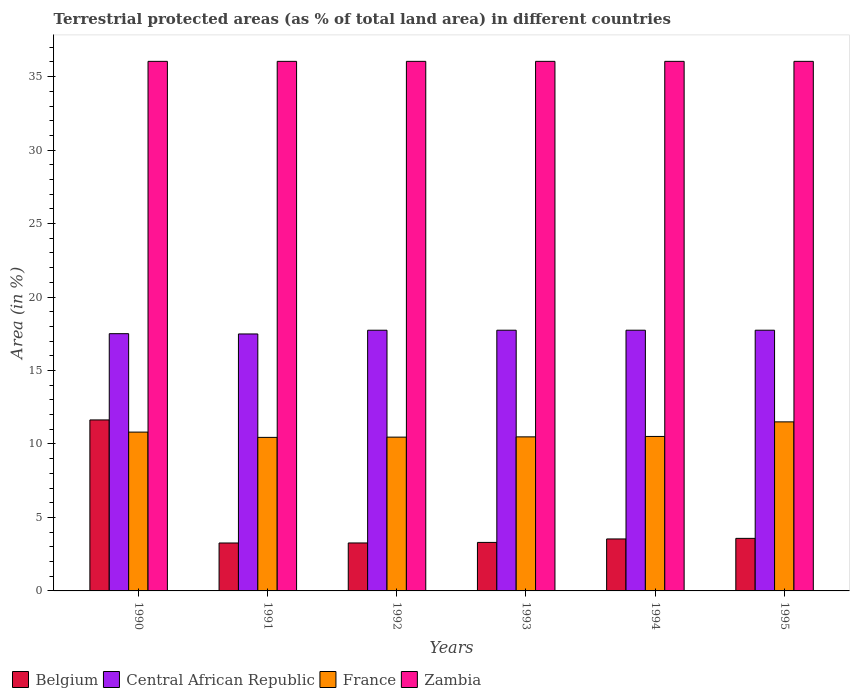How many different coloured bars are there?
Your response must be concise. 4. How many groups of bars are there?
Give a very brief answer. 6. Are the number of bars on each tick of the X-axis equal?
Keep it short and to the point. Yes. What is the percentage of terrestrial protected land in France in 1991?
Your response must be concise. 10.45. Across all years, what is the maximum percentage of terrestrial protected land in France?
Ensure brevity in your answer.  11.51. Across all years, what is the minimum percentage of terrestrial protected land in Belgium?
Offer a terse response. 3.26. In which year was the percentage of terrestrial protected land in Zambia maximum?
Keep it short and to the point. 1990. What is the total percentage of terrestrial protected land in Belgium in the graph?
Offer a terse response. 28.58. What is the difference between the percentage of terrestrial protected land in Zambia in 1992 and that in 1995?
Provide a short and direct response. 0. What is the difference between the percentage of terrestrial protected land in Zambia in 1992 and the percentage of terrestrial protected land in Central African Republic in 1993?
Offer a very short reply. 18.3. What is the average percentage of terrestrial protected land in Belgium per year?
Give a very brief answer. 4.76. In the year 1995, what is the difference between the percentage of terrestrial protected land in Belgium and percentage of terrestrial protected land in Zambia?
Your answer should be compact. -32.47. What is the ratio of the percentage of terrestrial protected land in France in 1990 to that in 1995?
Offer a terse response. 0.94. Is the difference between the percentage of terrestrial protected land in Belgium in 1990 and 1993 greater than the difference between the percentage of terrestrial protected land in Zambia in 1990 and 1993?
Make the answer very short. Yes. What is the difference between the highest and the second highest percentage of terrestrial protected land in Zambia?
Ensure brevity in your answer.  0. What is the difference between the highest and the lowest percentage of terrestrial protected land in Zambia?
Your answer should be very brief. 0. Is it the case that in every year, the sum of the percentage of terrestrial protected land in Belgium and percentage of terrestrial protected land in Zambia is greater than the sum of percentage of terrestrial protected land in France and percentage of terrestrial protected land in Central African Republic?
Offer a terse response. No. What does the 1st bar from the left in 1990 represents?
Your response must be concise. Belgium. What does the 3rd bar from the right in 1992 represents?
Keep it short and to the point. Central African Republic. How many bars are there?
Your response must be concise. 24. Are all the bars in the graph horizontal?
Give a very brief answer. No. Are the values on the major ticks of Y-axis written in scientific E-notation?
Offer a terse response. No. Does the graph contain grids?
Your answer should be compact. No. Where does the legend appear in the graph?
Your answer should be compact. Bottom left. What is the title of the graph?
Your response must be concise. Terrestrial protected areas (as % of total land area) in different countries. Does "Croatia" appear as one of the legend labels in the graph?
Make the answer very short. No. What is the label or title of the X-axis?
Your answer should be compact. Years. What is the label or title of the Y-axis?
Your answer should be compact. Area (in %). What is the Area (in %) of Belgium in 1990?
Offer a terse response. 11.64. What is the Area (in %) of Central African Republic in 1990?
Ensure brevity in your answer.  17.51. What is the Area (in %) of France in 1990?
Your answer should be very brief. 10.81. What is the Area (in %) of Zambia in 1990?
Your answer should be very brief. 36.04. What is the Area (in %) in Belgium in 1991?
Your response must be concise. 3.26. What is the Area (in %) of Central African Republic in 1991?
Offer a terse response. 17.49. What is the Area (in %) in France in 1991?
Give a very brief answer. 10.45. What is the Area (in %) in Zambia in 1991?
Provide a succinct answer. 36.04. What is the Area (in %) in Belgium in 1992?
Offer a very short reply. 3.26. What is the Area (in %) of Central African Republic in 1992?
Provide a short and direct response. 17.74. What is the Area (in %) of France in 1992?
Give a very brief answer. 10.47. What is the Area (in %) in Zambia in 1992?
Provide a succinct answer. 36.04. What is the Area (in %) of Belgium in 1993?
Provide a short and direct response. 3.3. What is the Area (in %) of Central African Republic in 1993?
Keep it short and to the point. 17.74. What is the Area (in %) of France in 1993?
Ensure brevity in your answer.  10.49. What is the Area (in %) in Zambia in 1993?
Give a very brief answer. 36.04. What is the Area (in %) of Belgium in 1994?
Your answer should be compact. 3.54. What is the Area (in %) in Central African Republic in 1994?
Your answer should be very brief. 17.74. What is the Area (in %) of France in 1994?
Your response must be concise. 10.51. What is the Area (in %) of Zambia in 1994?
Give a very brief answer. 36.04. What is the Area (in %) in Belgium in 1995?
Provide a short and direct response. 3.58. What is the Area (in %) in Central African Republic in 1995?
Keep it short and to the point. 17.74. What is the Area (in %) of France in 1995?
Provide a short and direct response. 11.51. What is the Area (in %) of Zambia in 1995?
Offer a terse response. 36.04. Across all years, what is the maximum Area (in %) in Belgium?
Your answer should be compact. 11.64. Across all years, what is the maximum Area (in %) in Central African Republic?
Provide a short and direct response. 17.74. Across all years, what is the maximum Area (in %) in France?
Provide a short and direct response. 11.51. Across all years, what is the maximum Area (in %) in Zambia?
Offer a terse response. 36.04. Across all years, what is the minimum Area (in %) of Belgium?
Keep it short and to the point. 3.26. Across all years, what is the minimum Area (in %) in Central African Republic?
Make the answer very short. 17.49. Across all years, what is the minimum Area (in %) of France?
Your answer should be compact. 10.45. Across all years, what is the minimum Area (in %) in Zambia?
Provide a short and direct response. 36.04. What is the total Area (in %) of Belgium in the graph?
Give a very brief answer. 28.58. What is the total Area (in %) in Central African Republic in the graph?
Your answer should be compact. 105.97. What is the total Area (in %) of France in the graph?
Offer a very short reply. 64.23. What is the total Area (in %) of Zambia in the graph?
Offer a terse response. 216.25. What is the difference between the Area (in %) of Belgium in 1990 and that in 1991?
Provide a short and direct response. 8.38. What is the difference between the Area (in %) of Central African Republic in 1990 and that in 1991?
Provide a succinct answer. 0.02. What is the difference between the Area (in %) in France in 1990 and that in 1991?
Offer a very short reply. 0.36. What is the difference between the Area (in %) in Zambia in 1990 and that in 1991?
Give a very brief answer. 0. What is the difference between the Area (in %) in Belgium in 1990 and that in 1992?
Offer a terse response. 8.37. What is the difference between the Area (in %) in Central African Republic in 1990 and that in 1992?
Make the answer very short. -0.24. What is the difference between the Area (in %) in France in 1990 and that in 1992?
Give a very brief answer. 0.34. What is the difference between the Area (in %) of Belgium in 1990 and that in 1993?
Offer a terse response. 8.34. What is the difference between the Area (in %) in Central African Republic in 1990 and that in 1993?
Ensure brevity in your answer.  -0.24. What is the difference between the Area (in %) in France in 1990 and that in 1993?
Keep it short and to the point. 0.32. What is the difference between the Area (in %) of Belgium in 1990 and that in 1994?
Provide a succinct answer. 8.1. What is the difference between the Area (in %) in Central African Republic in 1990 and that in 1994?
Provide a short and direct response. -0.24. What is the difference between the Area (in %) of France in 1990 and that in 1994?
Give a very brief answer. 0.3. What is the difference between the Area (in %) of Belgium in 1990 and that in 1995?
Offer a very short reply. 8.06. What is the difference between the Area (in %) in Central African Republic in 1990 and that in 1995?
Give a very brief answer. -0.24. What is the difference between the Area (in %) in France in 1990 and that in 1995?
Provide a succinct answer. -0.7. What is the difference between the Area (in %) in Belgium in 1991 and that in 1992?
Your response must be concise. -0. What is the difference between the Area (in %) of Central African Republic in 1991 and that in 1992?
Keep it short and to the point. -0.25. What is the difference between the Area (in %) in France in 1991 and that in 1992?
Make the answer very short. -0.02. What is the difference between the Area (in %) in Belgium in 1991 and that in 1993?
Offer a terse response. -0.04. What is the difference between the Area (in %) in Central African Republic in 1991 and that in 1993?
Offer a very short reply. -0.26. What is the difference between the Area (in %) of France in 1991 and that in 1993?
Your answer should be compact. -0.04. What is the difference between the Area (in %) of Zambia in 1991 and that in 1993?
Your answer should be very brief. 0. What is the difference between the Area (in %) in Belgium in 1991 and that in 1994?
Your answer should be very brief. -0.27. What is the difference between the Area (in %) in Central African Republic in 1991 and that in 1994?
Offer a terse response. -0.26. What is the difference between the Area (in %) of France in 1991 and that in 1994?
Provide a short and direct response. -0.06. What is the difference between the Area (in %) in Belgium in 1991 and that in 1995?
Your answer should be very brief. -0.31. What is the difference between the Area (in %) of Central African Republic in 1991 and that in 1995?
Provide a short and direct response. -0.26. What is the difference between the Area (in %) in France in 1991 and that in 1995?
Provide a short and direct response. -1.06. What is the difference between the Area (in %) of Belgium in 1992 and that in 1993?
Ensure brevity in your answer.  -0.04. What is the difference between the Area (in %) of Central African Republic in 1992 and that in 1993?
Your response must be concise. -0. What is the difference between the Area (in %) of France in 1992 and that in 1993?
Ensure brevity in your answer.  -0.02. What is the difference between the Area (in %) of Zambia in 1992 and that in 1993?
Your answer should be compact. 0. What is the difference between the Area (in %) in Belgium in 1992 and that in 1994?
Offer a very short reply. -0.27. What is the difference between the Area (in %) in Central African Republic in 1992 and that in 1994?
Ensure brevity in your answer.  -0. What is the difference between the Area (in %) of France in 1992 and that in 1994?
Give a very brief answer. -0.05. What is the difference between the Area (in %) of Zambia in 1992 and that in 1994?
Provide a short and direct response. 0. What is the difference between the Area (in %) in Belgium in 1992 and that in 1995?
Give a very brief answer. -0.31. What is the difference between the Area (in %) of Central African Republic in 1992 and that in 1995?
Ensure brevity in your answer.  -0. What is the difference between the Area (in %) in France in 1992 and that in 1995?
Provide a succinct answer. -1.04. What is the difference between the Area (in %) of Zambia in 1992 and that in 1995?
Provide a succinct answer. 0. What is the difference between the Area (in %) of Belgium in 1993 and that in 1994?
Offer a very short reply. -0.24. What is the difference between the Area (in %) in Central African Republic in 1993 and that in 1994?
Ensure brevity in your answer.  0. What is the difference between the Area (in %) in France in 1993 and that in 1994?
Ensure brevity in your answer.  -0.03. What is the difference between the Area (in %) of Belgium in 1993 and that in 1995?
Your response must be concise. -0.28. What is the difference between the Area (in %) of Central African Republic in 1993 and that in 1995?
Keep it short and to the point. 0. What is the difference between the Area (in %) in France in 1993 and that in 1995?
Give a very brief answer. -1.02. What is the difference between the Area (in %) of Zambia in 1993 and that in 1995?
Provide a short and direct response. 0. What is the difference between the Area (in %) of Belgium in 1994 and that in 1995?
Give a very brief answer. -0.04. What is the difference between the Area (in %) in France in 1994 and that in 1995?
Provide a succinct answer. -0.99. What is the difference between the Area (in %) of Zambia in 1994 and that in 1995?
Provide a short and direct response. 0. What is the difference between the Area (in %) in Belgium in 1990 and the Area (in %) in Central African Republic in 1991?
Make the answer very short. -5.85. What is the difference between the Area (in %) in Belgium in 1990 and the Area (in %) in France in 1991?
Provide a short and direct response. 1.19. What is the difference between the Area (in %) in Belgium in 1990 and the Area (in %) in Zambia in 1991?
Offer a very short reply. -24.4. What is the difference between the Area (in %) in Central African Republic in 1990 and the Area (in %) in France in 1991?
Provide a succinct answer. 7.06. What is the difference between the Area (in %) in Central African Republic in 1990 and the Area (in %) in Zambia in 1991?
Ensure brevity in your answer.  -18.53. What is the difference between the Area (in %) in France in 1990 and the Area (in %) in Zambia in 1991?
Provide a short and direct response. -25.23. What is the difference between the Area (in %) of Belgium in 1990 and the Area (in %) of Central African Republic in 1992?
Provide a short and direct response. -6.11. What is the difference between the Area (in %) of Belgium in 1990 and the Area (in %) of France in 1992?
Offer a terse response. 1.17. What is the difference between the Area (in %) of Belgium in 1990 and the Area (in %) of Zambia in 1992?
Make the answer very short. -24.4. What is the difference between the Area (in %) of Central African Republic in 1990 and the Area (in %) of France in 1992?
Your response must be concise. 7.04. What is the difference between the Area (in %) in Central African Republic in 1990 and the Area (in %) in Zambia in 1992?
Your answer should be very brief. -18.53. What is the difference between the Area (in %) of France in 1990 and the Area (in %) of Zambia in 1992?
Offer a terse response. -25.23. What is the difference between the Area (in %) of Belgium in 1990 and the Area (in %) of Central African Republic in 1993?
Your answer should be very brief. -6.11. What is the difference between the Area (in %) of Belgium in 1990 and the Area (in %) of France in 1993?
Your answer should be very brief. 1.15. What is the difference between the Area (in %) of Belgium in 1990 and the Area (in %) of Zambia in 1993?
Your answer should be very brief. -24.4. What is the difference between the Area (in %) of Central African Republic in 1990 and the Area (in %) of France in 1993?
Your response must be concise. 7.02. What is the difference between the Area (in %) in Central African Republic in 1990 and the Area (in %) in Zambia in 1993?
Provide a short and direct response. -18.53. What is the difference between the Area (in %) in France in 1990 and the Area (in %) in Zambia in 1993?
Offer a terse response. -25.23. What is the difference between the Area (in %) of Belgium in 1990 and the Area (in %) of Central African Republic in 1994?
Provide a succinct answer. -6.11. What is the difference between the Area (in %) in Belgium in 1990 and the Area (in %) in France in 1994?
Your answer should be compact. 1.12. What is the difference between the Area (in %) in Belgium in 1990 and the Area (in %) in Zambia in 1994?
Your answer should be very brief. -24.4. What is the difference between the Area (in %) in Central African Republic in 1990 and the Area (in %) in France in 1994?
Make the answer very short. 6.99. What is the difference between the Area (in %) of Central African Republic in 1990 and the Area (in %) of Zambia in 1994?
Your response must be concise. -18.53. What is the difference between the Area (in %) of France in 1990 and the Area (in %) of Zambia in 1994?
Make the answer very short. -25.23. What is the difference between the Area (in %) in Belgium in 1990 and the Area (in %) in Central African Republic in 1995?
Your response must be concise. -6.11. What is the difference between the Area (in %) in Belgium in 1990 and the Area (in %) in France in 1995?
Your response must be concise. 0.13. What is the difference between the Area (in %) in Belgium in 1990 and the Area (in %) in Zambia in 1995?
Offer a terse response. -24.4. What is the difference between the Area (in %) in Central African Republic in 1990 and the Area (in %) in France in 1995?
Your answer should be compact. 6. What is the difference between the Area (in %) in Central African Republic in 1990 and the Area (in %) in Zambia in 1995?
Give a very brief answer. -18.53. What is the difference between the Area (in %) of France in 1990 and the Area (in %) of Zambia in 1995?
Provide a short and direct response. -25.23. What is the difference between the Area (in %) in Belgium in 1991 and the Area (in %) in Central African Republic in 1992?
Keep it short and to the point. -14.48. What is the difference between the Area (in %) of Belgium in 1991 and the Area (in %) of France in 1992?
Your answer should be compact. -7.2. What is the difference between the Area (in %) of Belgium in 1991 and the Area (in %) of Zambia in 1992?
Offer a terse response. -32.78. What is the difference between the Area (in %) of Central African Republic in 1991 and the Area (in %) of France in 1992?
Make the answer very short. 7.02. What is the difference between the Area (in %) in Central African Republic in 1991 and the Area (in %) in Zambia in 1992?
Keep it short and to the point. -18.55. What is the difference between the Area (in %) in France in 1991 and the Area (in %) in Zambia in 1992?
Your response must be concise. -25.59. What is the difference between the Area (in %) of Belgium in 1991 and the Area (in %) of Central African Republic in 1993?
Offer a terse response. -14.48. What is the difference between the Area (in %) of Belgium in 1991 and the Area (in %) of France in 1993?
Offer a very short reply. -7.22. What is the difference between the Area (in %) of Belgium in 1991 and the Area (in %) of Zambia in 1993?
Your answer should be very brief. -32.78. What is the difference between the Area (in %) of Central African Republic in 1991 and the Area (in %) of France in 1993?
Your response must be concise. 7. What is the difference between the Area (in %) in Central African Republic in 1991 and the Area (in %) in Zambia in 1993?
Make the answer very short. -18.55. What is the difference between the Area (in %) of France in 1991 and the Area (in %) of Zambia in 1993?
Offer a terse response. -25.59. What is the difference between the Area (in %) in Belgium in 1991 and the Area (in %) in Central African Republic in 1994?
Your answer should be very brief. -14.48. What is the difference between the Area (in %) in Belgium in 1991 and the Area (in %) in France in 1994?
Ensure brevity in your answer.  -7.25. What is the difference between the Area (in %) of Belgium in 1991 and the Area (in %) of Zambia in 1994?
Provide a succinct answer. -32.78. What is the difference between the Area (in %) of Central African Republic in 1991 and the Area (in %) of France in 1994?
Give a very brief answer. 6.98. What is the difference between the Area (in %) in Central African Republic in 1991 and the Area (in %) in Zambia in 1994?
Your answer should be compact. -18.55. What is the difference between the Area (in %) in France in 1991 and the Area (in %) in Zambia in 1994?
Offer a very short reply. -25.59. What is the difference between the Area (in %) in Belgium in 1991 and the Area (in %) in Central African Republic in 1995?
Provide a short and direct response. -14.48. What is the difference between the Area (in %) of Belgium in 1991 and the Area (in %) of France in 1995?
Offer a very short reply. -8.24. What is the difference between the Area (in %) in Belgium in 1991 and the Area (in %) in Zambia in 1995?
Your answer should be very brief. -32.78. What is the difference between the Area (in %) of Central African Republic in 1991 and the Area (in %) of France in 1995?
Keep it short and to the point. 5.98. What is the difference between the Area (in %) in Central African Republic in 1991 and the Area (in %) in Zambia in 1995?
Your answer should be compact. -18.55. What is the difference between the Area (in %) of France in 1991 and the Area (in %) of Zambia in 1995?
Your response must be concise. -25.59. What is the difference between the Area (in %) of Belgium in 1992 and the Area (in %) of Central African Republic in 1993?
Offer a terse response. -14.48. What is the difference between the Area (in %) of Belgium in 1992 and the Area (in %) of France in 1993?
Ensure brevity in your answer.  -7.22. What is the difference between the Area (in %) of Belgium in 1992 and the Area (in %) of Zambia in 1993?
Your answer should be very brief. -32.78. What is the difference between the Area (in %) of Central African Republic in 1992 and the Area (in %) of France in 1993?
Your response must be concise. 7.26. What is the difference between the Area (in %) of Central African Republic in 1992 and the Area (in %) of Zambia in 1993?
Keep it short and to the point. -18.3. What is the difference between the Area (in %) of France in 1992 and the Area (in %) of Zambia in 1993?
Provide a succinct answer. -25.57. What is the difference between the Area (in %) in Belgium in 1992 and the Area (in %) in Central African Republic in 1994?
Make the answer very short. -14.48. What is the difference between the Area (in %) in Belgium in 1992 and the Area (in %) in France in 1994?
Provide a short and direct response. -7.25. What is the difference between the Area (in %) in Belgium in 1992 and the Area (in %) in Zambia in 1994?
Provide a short and direct response. -32.78. What is the difference between the Area (in %) in Central African Republic in 1992 and the Area (in %) in France in 1994?
Your answer should be very brief. 7.23. What is the difference between the Area (in %) in Central African Republic in 1992 and the Area (in %) in Zambia in 1994?
Make the answer very short. -18.3. What is the difference between the Area (in %) of France in 1992 and the Area (in %) of Zambia in 1994?
Offer a terse response. -25.57. What is the difference between the Area (in %) in Belgium in 1992 and the Area (in %) in Central African Republic in 1995?
Give a very brief answer. -14.48. What is the difference between the Area (in %) of Belgium in 1992 and the Area (in %) of France in 1995?
Offer a very short reply. -8.24. What is the difference between the Area (in %) in Belgium in 1992 and the Area (in %) in Zambia in 1995?
Your response must be concise. -32.78. What is the difference between the Area (in %) in Central African Republic in 1992 and the Area (in %) in France in 1995?
Keep it short and to the point. 6.24. What is the difference between the Area (in %) of Central African Republic in 1992 and the Area (in %) of Zambia in 1995?
Provide a succinct answer. -18.3. What is the difference between the Area (in %) in France in 1992 and the Area (in %) in Zambia in 1995?
Offer a terse response. -25.57. What is the difference between the Area (in %) of Belgium in 1993 and the Area (in %) of Central African Republic in 1994?
Give a very brief answer. -14.44. What is the difference between the Area (in %) in Belgium in 1993 and the Area (in %) in France in 1994?
Offer a very short reply. -7.21. What is the difference between the Area (in %) in Belgium in 1993 and the Area (in %) in Zambia in 1994?
Provide a short and direct response. -32.74. What is the difference between the Area (in %) of Central African Republic in 1993 and the Area (in %) of France in 1994?
Your answer should be very brief. 7.23. What is the difference between the Area (in %) in Central African Republic in 1993 and the Area (in %) in Zambia in 1994?
Keep it short and to the point. -18.3. What is the difference between the Area (in %) in France in 1993 and the Area (in %) in Zambia in 1994?
Provide a short and direct response. -25.56. What is the difference between the Area (in %) of Belgium in 1993 and the Area (in %) of Central African Republic in 1995?
Offer a very short reply. -14.44. What is the difference between the Area (in %) in Belgium in 1993 and the Area (in %) in France in 1995?
Offer a terse response. -8.2. What is the difference between the Area (in %) of Belgium in 1993 and the Area (in %) of Zambia in 1995?
Provide a short and direct response. -32.74. What is the difference between the Area (in %) of Central African Republic in 1993 and the Area (in %) of France in 1995?
Your answer should be compact. 6.24. What is the difference between the Area (in %) in Central African Republic in 1993 and the Area (in %) in Zambia in 1995?
Keep it short and to the point. -18.3. What is the difference between the Area (in %) in France in 1993 and the Area (in %) in Zambia in 1995?
Your answer should be compact. -25.56. What is the difference between the Area (in %) in Belgium in 1994 and the Area (in %) in Central African Republic in 1995?
Ensure brevity in your answer.  -14.21. What is the difference between the Area (in %) in Belgium in 1994 and the Area (in %) in France in 1995?
Offer a terse response. -7.97. What is the difference between the Area (in %) in Belgium in 1994 and the Area (in %) in Zambia in 1995?
Provide a succinct answer. -32.51. What is the difference between the Area (in %) of Central African Republic in 1994 and the Area (in %) of France in 1995?
Provide a short and direct response. 6.24. What is the difference between the Area (in %) of Central African Republic in 1994 and the Area (in %) of Zambia in 1995?
Offer a very short reply. -18.3. What is the difference between the Area (in %) in France in 1994 and the Area (in %) in Zambia in 1995?
Offer a very short reply. -25.53. What is the average Area (in %) of Belgium per year?
Keep it short and to the point. 4.76. What is the average Area (in %) in Central African Republic per year?
Your answer should be very brief. 17.66. What is the average Area (in %) in France per year?
Offer a terse response. 10.71. What is the average Area (in %) in Zambia per year?
Your answer should be very brief. 36.04. In the year 1990, what is the difference between the Area (in %) in Belgium and Area (in %) in Central African Republic?
Ensure brevity in your answer.  -5.87. In the year 1990, what is the difference between the Area (in %) of Belgium and Area (in %) of France?
Keep it short and to the point. 0.83. In the year 1990, what is the difference between the Area (in %) of Belgium and Area (in %) of Zambia?
Your answer should be very brief. -24.4. In the year 1990, what is the difference between the Area (in %) in Central African Republic and Area (in %) in France?
Keep it short and to the point. 6.7. In the year 1990, what is the difference between the Area (in %) in Central African Republic and Area (in %) in Zambia?
Offer a very short reply. -18.53. In the year 1990, what is the difference between the Area (in %) in France and Area (in %) in Zambia?
Your answer should be very brief. -25.23. In the year 1991, what is the difference between the Area (in %) in Belgium and Area (in %) in Central African Republic?
Offer a very short reply. -14.23. In the year 1991, what is the difference between the Area (in %) of Belgium and Area (in %) of France?
Provide a short and direct response. -7.19. In the year 1991, what is the difference between the Area (in %) in Belgium and Area (in %) in Zambia?
Offer a very short reply. -32.78. In the year 1991, what is the difference between the Area (in %) in Central African Republic and Area (in %) in France?
Your answer should be compact. 7.04. In the year 1991, what is the difference between the Area (in %) of Central African Republic and Area (in %) of Zambia?
Keep it short and to the point. -18.55. In the year 1991, what is the difference between the Area (in %) of France and Area (in %) of Zambia?
Ensure brevity in your answer.  -25.59. In the year 1992, what is the difference between the Area (in %) of Belgium and Area (in %) of Central African Republic?
Your answer should be very brief. -14.48. In the year 1992, what is the difference between the Area (in %) in Belgium and Area (in %) in France?
Keep it short and to the point. -7.2. In the year 1992, what is the difference between the Area (in %) of Belgium and Area (in %) of Zambia?
Your response must be concise. -32.78. In the year 1992, what is the difference between the Area (in %) of Central African Republic and Area (in %) of France?
Provide a short and direct response. 7.28. In the year 1992, what is the difference between the Area (in %) in Central African Republic and Area (in %) in Zambia?
Your response must be concise. -18.3. In the year 1992, what is the difference between the Area (in %) in France and Area (in %) in Zambia?
Provide a succinct answer. -25.57. In the year 1993, what is the difference between the Area (in %) in Belgium and Area (in %) in Central African Republic?
Provide a short and direct response. -14.44. In the year 1993, what is the difference between the Area (in %) in Belgium and Area (in %) in France?
Give a very brief answer. -7.18. In the year 1993, what is the difference between the Area (in %) of Belgium and Area (in %) of Zambia?
Your response must be concise. -32.74. In the year 1993, what is the difference between the Area (in %) of Central African Republic and Area (in %) of France?
Provide a succinct answer. 7.26. In the year 1993, what is the difference between the Area (in %) in Central African Republic and Area (in %) in Zambia?
Provide a succinct answer. -18.3. In the year 1993, what is the difference between the Area (in %) in France and Area (in %) in Zambia?
Your answer should be compact. -25.56. In the year 1994, what is the difference between the Area (in %) in Belgium and Area (in %) in Central African Republic?
Your answer should be very brief. -14.21. In the year 1994, what is the difference between the Area (in %) of Belgium and Area (in %) of France?
Your response must be concise. -6.98. In the year 1994, what is the difference between the Area (in %) in Belgium and Area (in %) in Zambia?
Offer a terse response. -32.51. In the year 1994, what is the difference between the Area (in %) in Central African Republic and Area (in %) in France?
Your answer should be very brief. 7.23. In the year 1994, what is the difference between the Area (in %) of Central African Republic and Area (in %) of Zambia?
Provide a succinct answer. -18.3. In the year 1994, what is the difference between the Area (in %) in France and Area (in %) in Zambia?
Keep it short and to the point. -25.53. In the year 1995, what is the difference between the Area (in %) of Belgium and Area (in %) of Central African Republic?
Provide a succinct answer. -14.17. In the year 1995, what is the difference between the Area (in %) in Belgium and Area (in %) in France?
Offer a terse response. -7.93. In the year 1995, what is the difference between the Area (in %) in Belgium and Area (in %) in Zambia?
Give a very brief answer. -32.47. In the year 1995, what is the difference between the Area (in %) in Central African Republic and Area (in %) in France?
Offer a very short reply. 6.24. In the year 1995, what is the difference between the Area (in %) of Central African Republic and Area (in %) of Zambia?
Provide a succinct answer. -18.3. In the year 1995, what is the difference between the Area (in %) of France and Area (in %) of Zambia?
Provide a short and direct response. -24.54. What is the ratio of the Area (in %) in Belgium in 1990 to that in 1991?
Your answer should be very brief. 3.57. What is the ratio of the Area (in %) of France in 1990 to that in 1991?
Your answer should be compact. 1.03. What is the ratio of the Area (in %) of Zambia in 1990 to that in 1991?
Provide a succinct answer. 1. What is the ratio of the Area (in %) of Belgium in 1990 to that in 1992?
Your answer should be compact. 3.57. What is the ratio of the Area (in %) of Central African Republic in 1990 to that in 1992?
Offer a very short reply. 0.99. What is the ratio of the Area (in %) in France in 1990 to that in 1992?
Give a very brief answer. 1.03. What is the ratio of the Area (in %) of Belgium in 1990 to that in 1993?
Give a very brief answer. 3.53. What is the ratio of the Area (in %) in Central African Republic in 1990 to that in 1993?
Provide a short and direct response. 0.99. What is the ratio of the Area (in %) of France in 1990 to that in 1993?
Your answer should be very brief. 1.03. What is the ratio of the Area (in %) of Zambia in 1990 to that in 1993?
Keep it short and to the point. 1. What is the ratio of the Area (in %) of Belgium in 1990 to that in 1994?
Your response must be concise. 3.29. What is the ratio of the Area (in %) in Central African Republic in 1990 to that in 1994?
Give a very brief answer. 0.99. What is the ratio of the Area (in %) in France in 1990 to that in 1994?
Make the answer very short. 1.03. What is the ratio of the Area (in %) in Belgium in 1990 to that in 1995?
Provide a short and direct response. 3.25. What is the ratio of the Area (in %) of Central African Republic in 1990 to that in 1995?
Your answer should be very brief. 0.99. What is the ratio of the Area (in %) of France in 1990 to that in 1995?
Offer a very short reply. 0.94. What is the ratio of the Area (in %) in Belgium in 1991 to that in 1992?
Provide a succinct answer. 1. What is the ratio of the Area (in %) of Central African Republic in 1991 to that in 1992?
Offer a terse response. 0.99. What is the ratio of the Area (in %) in France in 1991 to that in 1992?
Give a very brief answer. 1. What is the ratio of the Area (in %) in Zambia in 1991 to that in 1992?
Make the answer very short. 1. What is the ratio of the Area (in %) of Belgium in 1991 to that in 1993?
Your response must be concise. 0.99. What is the ratio of the Area (in %) of Central African Republic in 1991 to that in 1993?
Provide a short and direct response. 0.99. What is the ratio of the Area (in %) in Zambia in 1991 to that in 1993?
Give a very brief answer. 1. What is the ratio of the Area (in %) of Belgium in 1991 to that in 1994?
Provide a short and direct response. 0.92. What is the ratio of the Area (in %) of Central African Republic in 1991 to that in 1994?
Give a very brief answer. 0.99. What is the ratio of the Area (in %) of Zambia in 1991 to that in 1994?
Offer a very short reply. 1. What is the ratio of the Area (in %) in Belgium in 1991 to that in 1995?
Your answer should be compact. 0.91. What is the ratio of the Area (in %) in Central African Republic in 1991 to that in 1995?
Provide a succinct answer. 0.99. What is the ratio of the Area (in %) of France in 1991 to that in 1995?
Your answer should be very brief. 0.91. What is the ratio of the Area (in %) in Belgium in 1992 to that in 1993?
Ensure brevity in your answer.  0.99. What is the ratio of the Area (in %) of Zambia in 1992 to that in 1993?
Your response must be concise. 1. What is the ratio of the Area (in %) of Belgium in 1992 to that in 1994?
Offer a very short reply. 0.92. What is the ratio of the Area (in %) of Belgium in 1992 to that in 1995?
Ensure brevity in your answer.  0.91. What is the ratio of the Area (in %) of Central African Republic in 1992 to that in 1995?
Provide a succinct answer. 1. What is the ratio of the Area (in %) of France in 1992 to that in 1995?
Give a very brief answer. 0.91. What is the ratio of the Area (in %) of Belgium in 1993 to that in 1994?
Keep it short and to the point. 0.93. What is the ratio of the Area (in %) of Central African Republic in 1993 to that in 1994?
Offer a terse response. 1. What is the ratio of the Area (in %) of Zambia in 1993 to that in 1994?
Provide a succinct answer. 1. What is the ratio of the Area (in %) in Belgium in 1993 to that in 1995?
Offer a terse response. 0.92. What is the ratio of the Area (in %) of France in 1993 to that in 1995?
Offer a very short reply. 0.91. What is the ratio of the Area (in %) of Belgium in 1994 to that in 1995?
Offer a very short reply. 0.99. What is the ratio of the Area (in %) of France in 1994 to that in 1995?
Ensure brevity in your answer.  0.91. What is the ratio of the Area (in %) of Zambia in 1994 to that in 1995?
Ensure brevity in your answer.  1. What is the difference between the highest and the second highest Area (in %) of Belgium?
Offer a very short reply. 8.06. What is the difference between the highest and the second highest Area (in %) of France?
Provide a succinct answer. 0.7. What is the difference between the highest and the second highest Area (in %) in Zambia?
Offer a very short reply. 0. What is the difference between the highest and the lowest Area (in %) in Belgium?
Give a very brief answer. 8.38. What is the difference between the highest and the lowest Area (in %) of Central African Republic?
Keep it short and to the point. 0.26. What is the difference between the highest and the lowest Area (in %) in France?
Offer a very short reply. 1.06. 